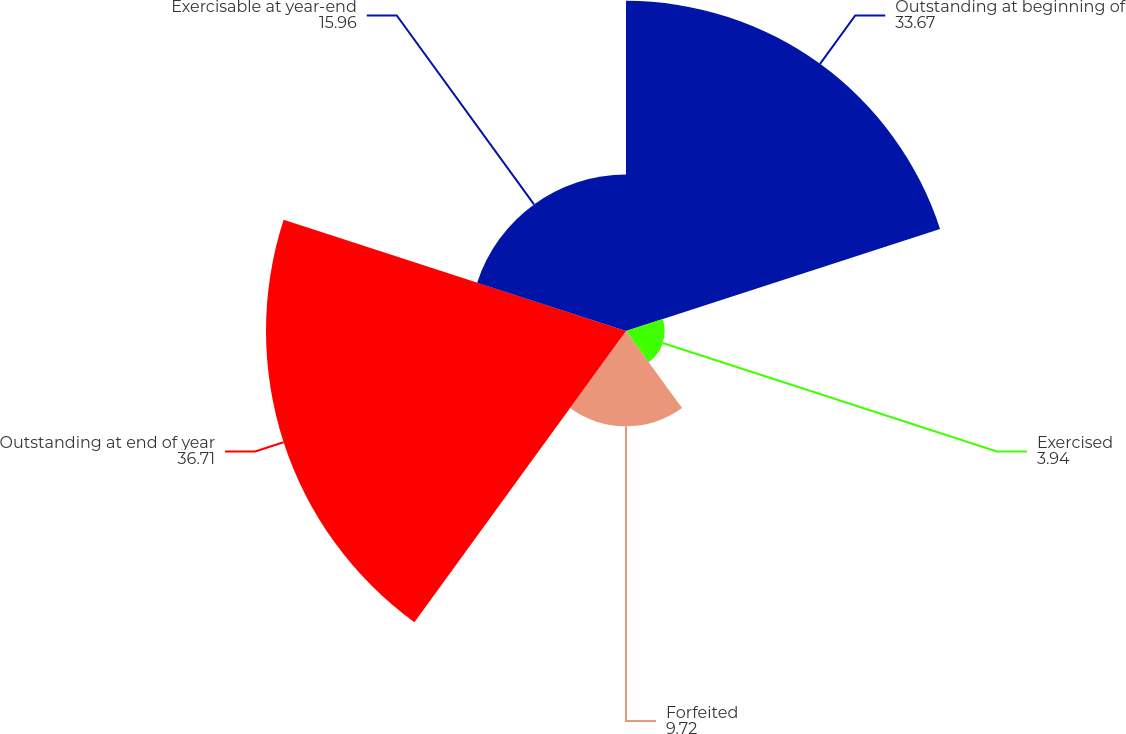Convert chart. <chart><loc_0><loc_0><loc_500><loc_500><pie_chart><fcel>Outstanding at beginning of<fcel>Exercised<fcel>Forfeited<fcel>Outstanding at end of year<fcel>Exercisable at year-end<nl><fcel>33.67%<fcel>3.94%<fcel>9.72%<fcel>36.71%<fcel>15.96%<nl></chart> 